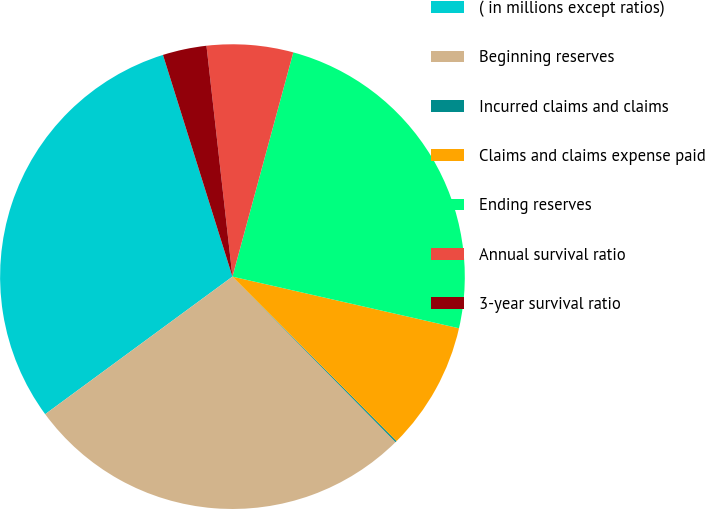Convert chart to OTSL. <chart><loc_0><loc_0><loc_500><loc_500><pie_chart><fcel>( in millions except ratios)<fcel>Beginning reserves<fcel>Incurred claims and claims<fcel>Claims and claims expense paid<fcel>Ending reserves<fcel>Annual survival ratio<fcel>3-year survival ratio<nl><fcel>30.25%<fcel>27.3%<fcel>0.1%<fcel>8.95%<fcel>24.35%<fcel>6.0%<fcel>3.05%<nl></chart> 